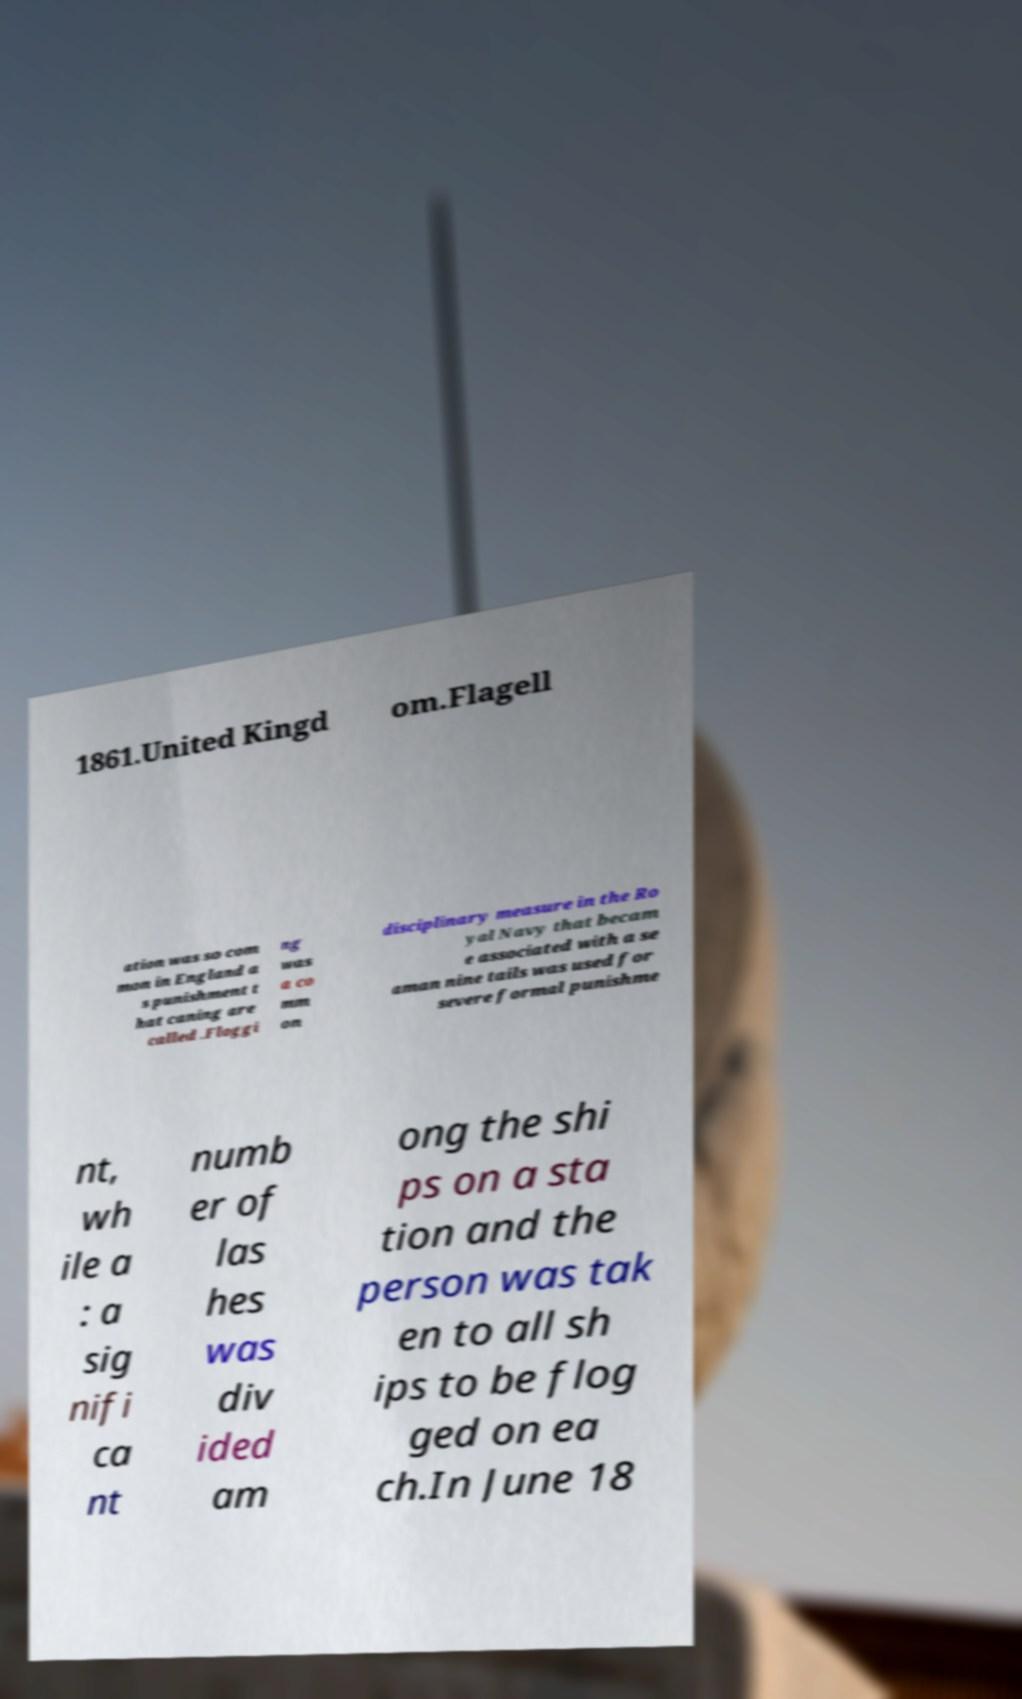Please read and relay the text visible in this image. What does it say? 1861.United Kingd om.Flagell ation was so com mon in England a s punishment t hat caning are called .Floggi ng was a co mm on disciplinary measure in the Ro yal Navy that becam e associated with a se aman nine tails was used for severe formal punishme nt, wh ile a : a sig nifi ca nt numb er of las hes was div ided am ong the shi ps on a sta tion and the person was tak en to all sh ips to be flog ged on ea ch.In June 18 